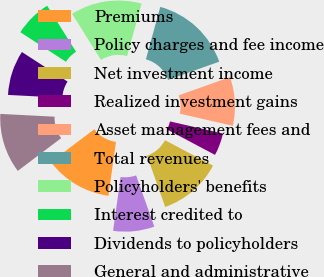Convert chart to OTSL. <chart><loc_0><loc_0><loc_500><loc_500><pie_chart><fcel>Premiums<fcel>Policy charges and fee income<fcel>Net investment income<fcel>Realized investment gains<fcel>Asset management fees and<fcel>Total revenues<fcel>Policyholders' benefits<fcel>Interest credited to<fcel>Dividends to policyholders<fcel>General and administrative<nl><fcel>12.5%<fcel>7.64%<fcel>11.81%<fcel>4.17%<fcel>9.03%<fcel>15.28%<fcel>13.19%<fcel>6.94%<fcel>8.33%<fcel>11.11%<nl></chart> 